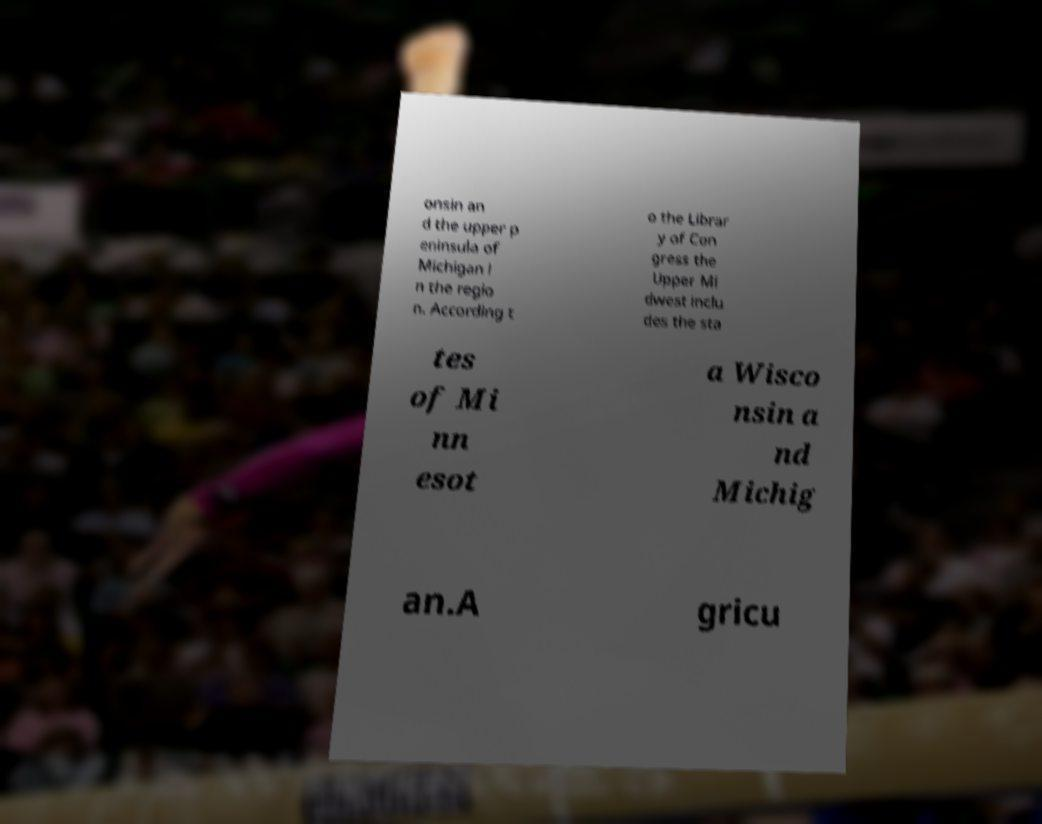Please read and relay the text visible in this image. What does it say? onsin an d the upper p eninsula of Michigan i n the regio n. According t o the Librar y of Con gress the Upper Mi dwest inclu des the sta tes of Mi nn esot a Wisco nsin a nd Michig an.A gricu 